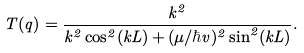<formula> <loc_0><loc_0><loc_500><loc_500>T ( q ) = \frac { k ^ { 2 } } { k ^ { 2 } \cos ^ { 2 } ( k L ) + ( \mu / \hbar { v } ) ^ { 2 } \sin ^ { 2 } ( k L ) } .</formula> 